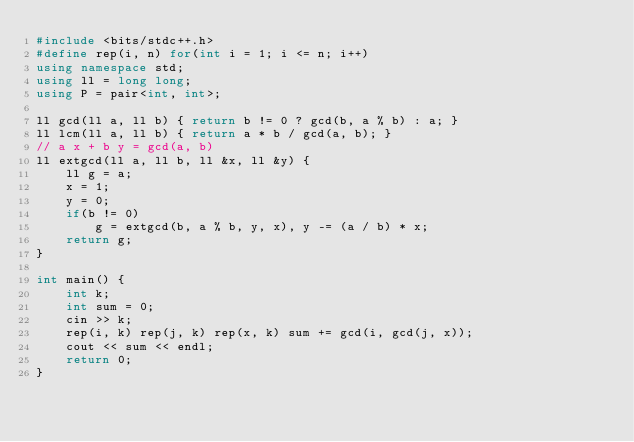<code> <loc_0><loc_0><loc_500><loc_500><_C++_>#include <bits/stdc++.h>
#define rep(i, n) for(int i = 1; i <= n; i++)
using namespace std;
using ll = long long;
using P = pair<int, int>;

ll gcd(ll a, ll b) { return b != 0 ? gcd(b, a % b) : a; }
ll lcm(ll a, ll b) { return a * b / gcd(a, b); }
// a x + b y = gcd(a, b)
ll extgcd(ll a, ll b, ll &x, ll &y) {
    ll g = a;
    x = 1;
    y = 0;
    if(b != 0)
        g = extgcd(b, a % b, y, x), y -= (a / b) * x;
    return g;
}

int main() {
    int k;
    int sum = 0;
    cin >> k;
    rep(i, k) rep(j, k) rep(x, k) sum += gcd(i, gcd(j, x));
    cout << sum << endl;
    return 0;
}</code> 